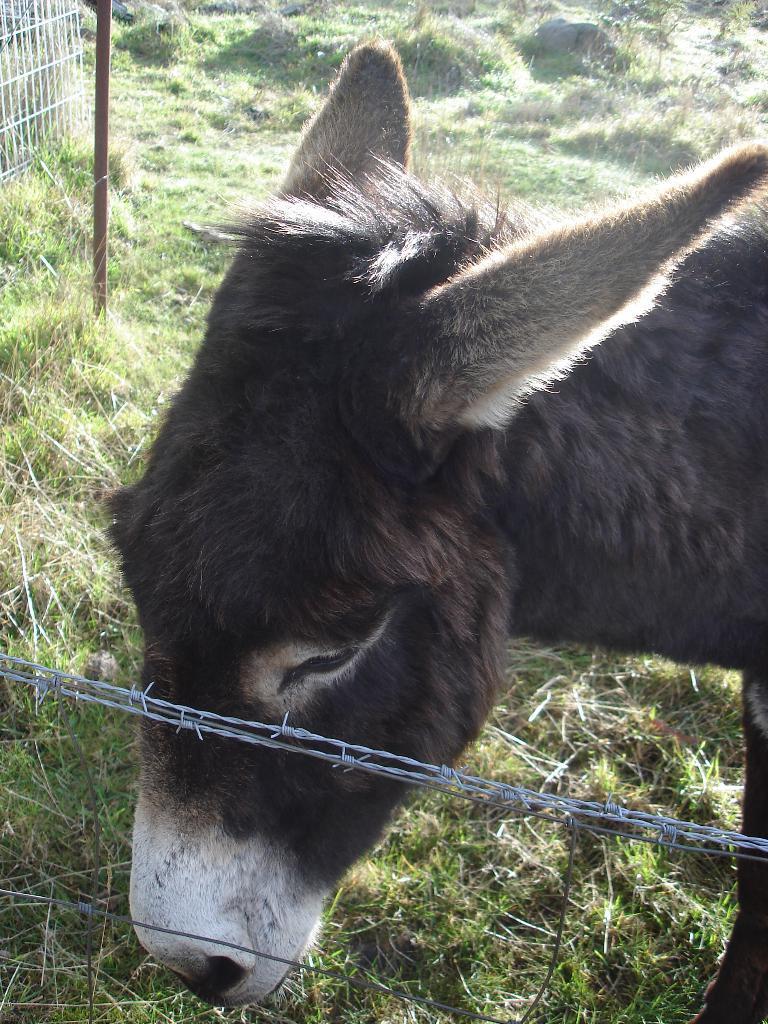In one or two sentences, can you explain what this image depicts? In this image, we can see an animal. Here we can see fencing wires. Background we can see grass. On the left side top of the image, we can see pole and grills. 